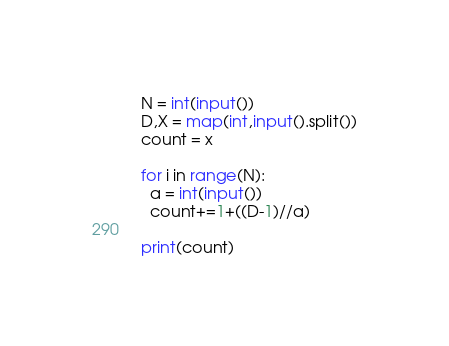<code> <loc_0><loc_0><loc_500><loc_500><_Python_>N = int(input())
D,X = map(int,input().split())
count = x

for i in range(N):
  a = int(input())
  count+=1+((D-1)//a)

print(count)

</code> 